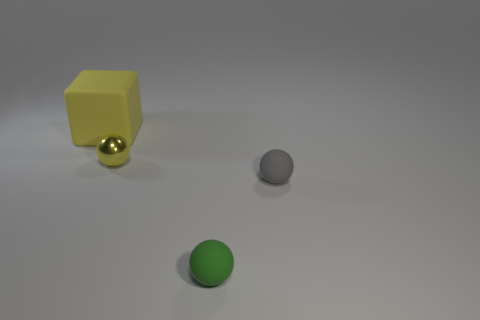Imagine if these objects were part of a larger scene. What kind of environment could they belong to? One can imagine these objects as part of a modern art installation or in an educational setting demonstrating shapes and colors. Depending on their sizes, they might also be seen as playthings in a child's room or objects on a designer's modeling desk. How might the lighting affect the mood or atmosphere of this scene? The soft, diffuse lighting creates a calm and neutral atmosphere. It highlights the objects without creating harsh shadows, which could suggest a setting that is intended for clear observation, such as a classroom, studio, or gallery. 